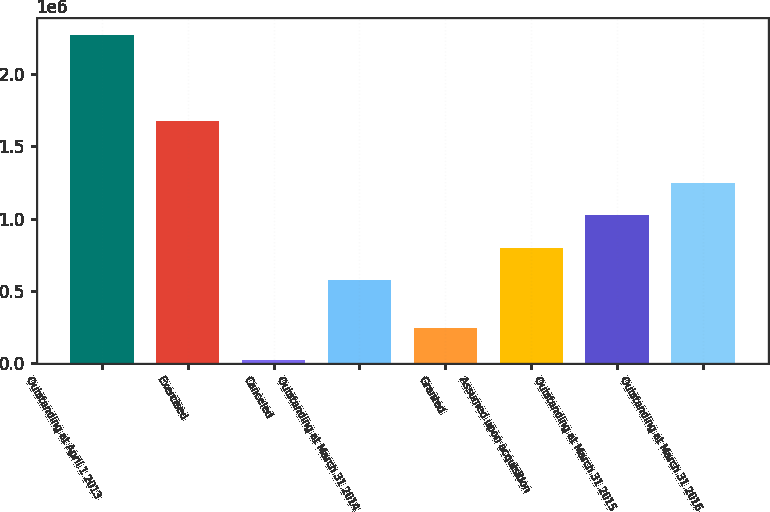<chart> <loc_0><loc_0><loc_500><loc_500><bar_chart><fcel>Outstanding at April 1 2013<fcel>Exercised<fcel>Canceled<fcel>Outstanding at March 31 2014<fcel>Granted<fcel>Assumed upon acquisition<fcel>Outstanding at March 31 2015<fcel>Outstanding at March 31 2016<nl><fcel>2.2698e+06<fcel>1.67566e+06<fcel>20529<fcel>573611<fcel>245456<fcel>798538<fcel>1.02347e+06<fcel>1.24839e+06<nl></chart> 